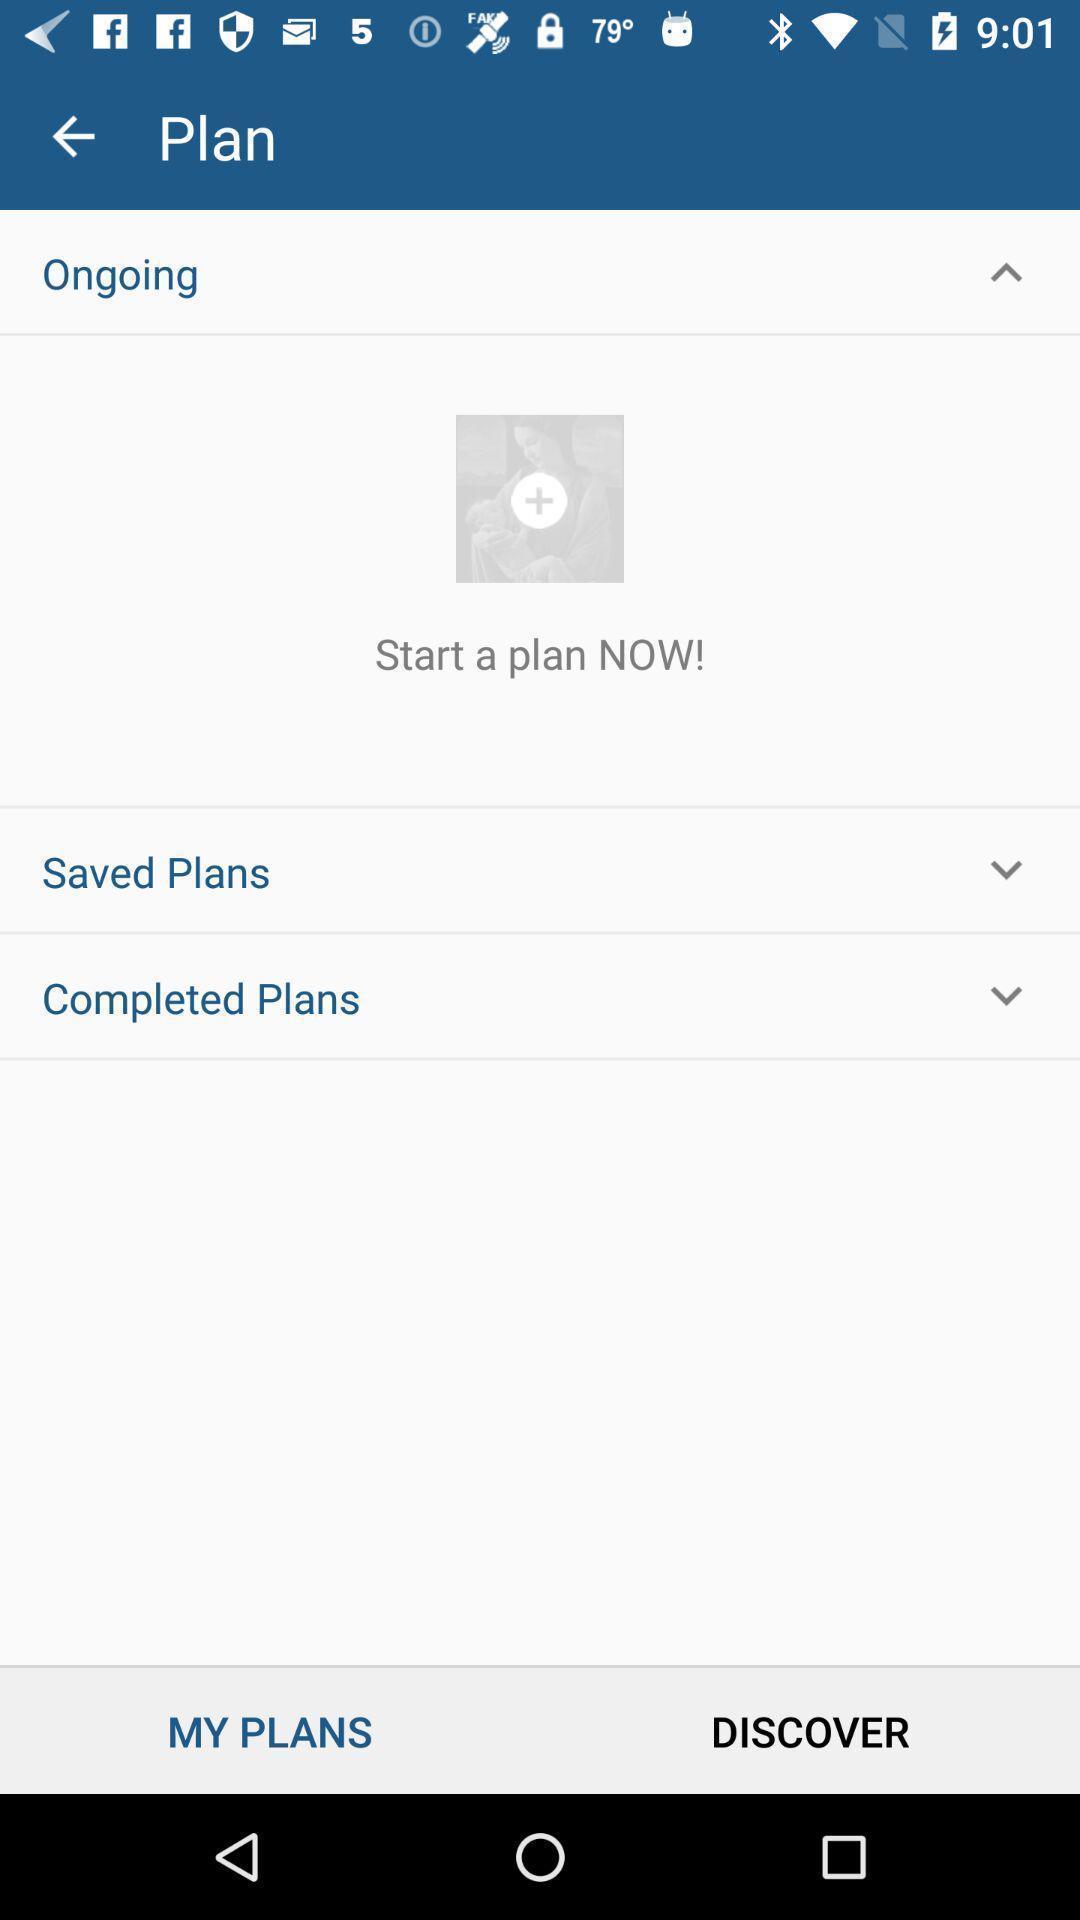Give me a narrative description of this picture. Screen displaying multiple planning options and an addon icon. 